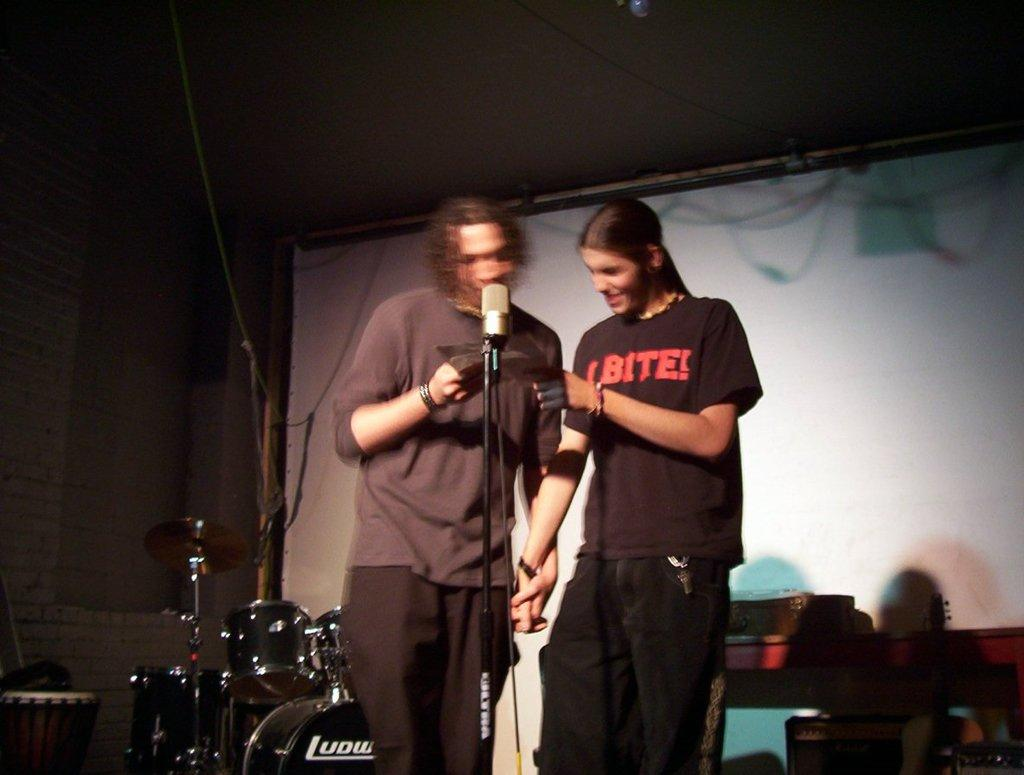How many people are present in the image? There are two men standing in the image. What object is placed in front of the men? There is a microphone (mic) in front of the men. What musical instrument can be seen in the background of the image? There are drums visible in the background of the image. What type of sweater is the crowd wearing in the image? There is no crowd present in the image, and therefore no sweater can be observed. 